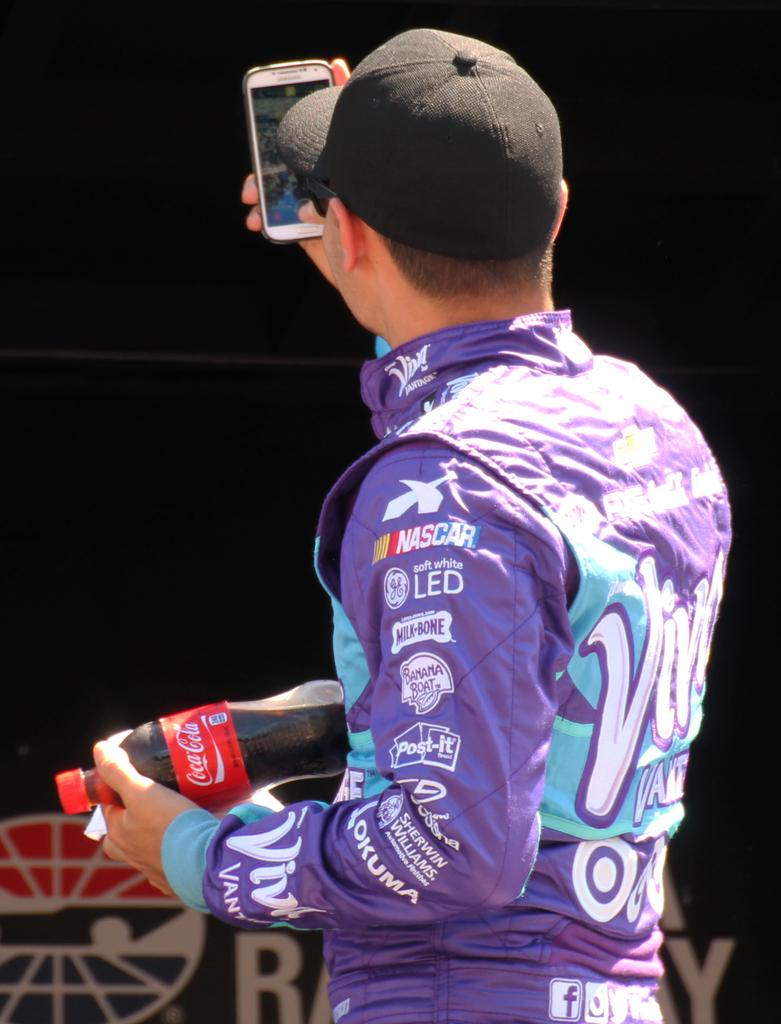Provide a one-sentence caption for the provided image. The back of a NASCAR driver dressed in purple jumpsuit carrying a coca cola bottle. 